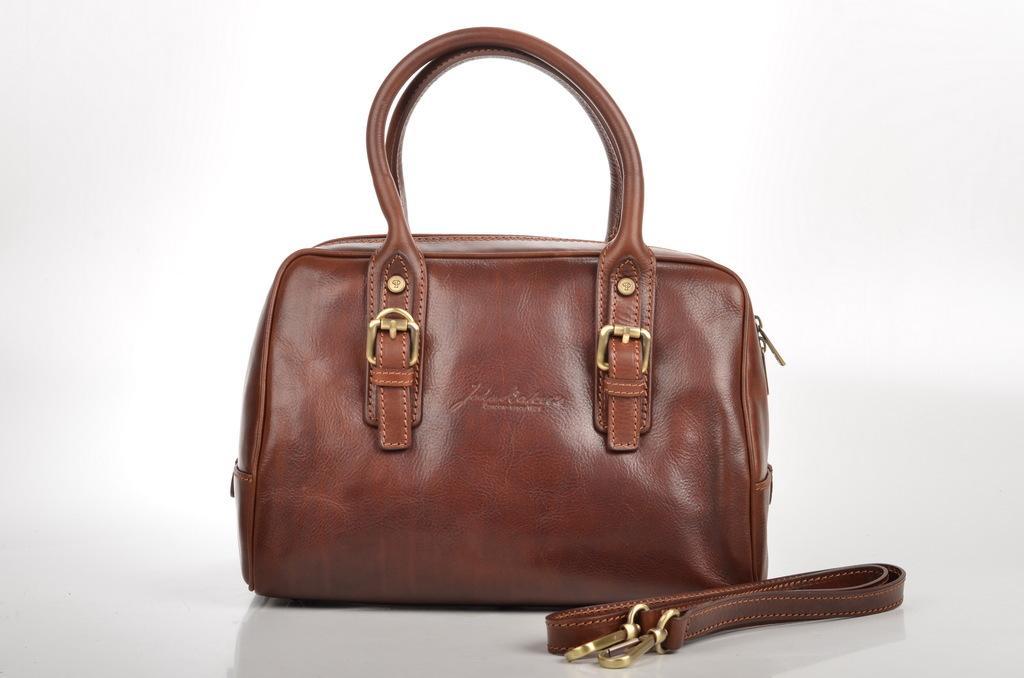Please provide a concise description of this image. There is a bag in the given picture which is in brown color placed on the table. There is a white background. 